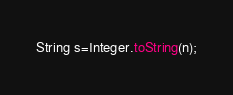Convert code to text. <code><loc_0><loc_0><loc_500><loc_500><_Java_>String s=Integer.toString(n);
</code> 